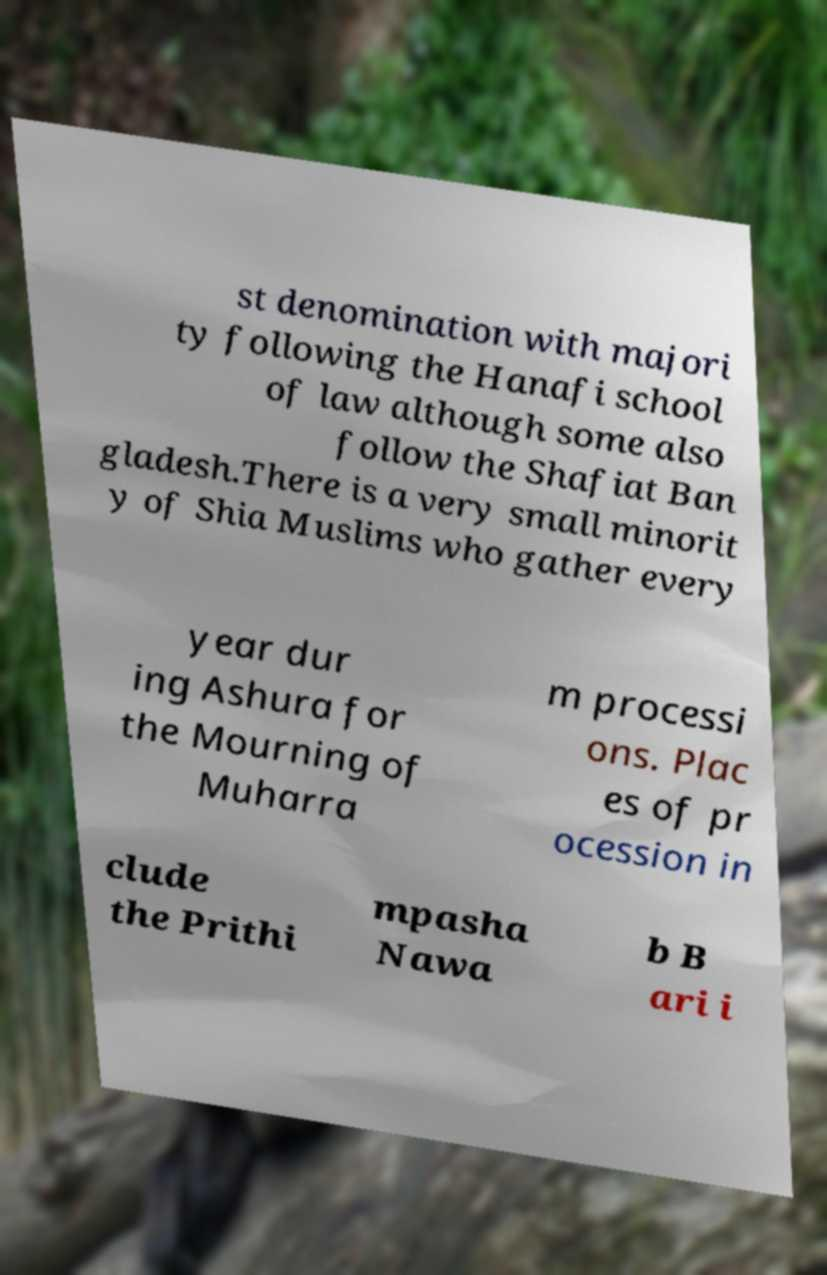I need the written content from this picture converted into text. Can you do that? st denomination with majori ty following the Hanafi school of law although some also follow the Shafiat Ban gladesh.There is a very small minorit y of Shia Muslims who gather every year dur ing Ashura for the Mourning of Muharra m processi ons. Plac es of pr ocession in clude the Prithi mpasha Nawa b B ari i 